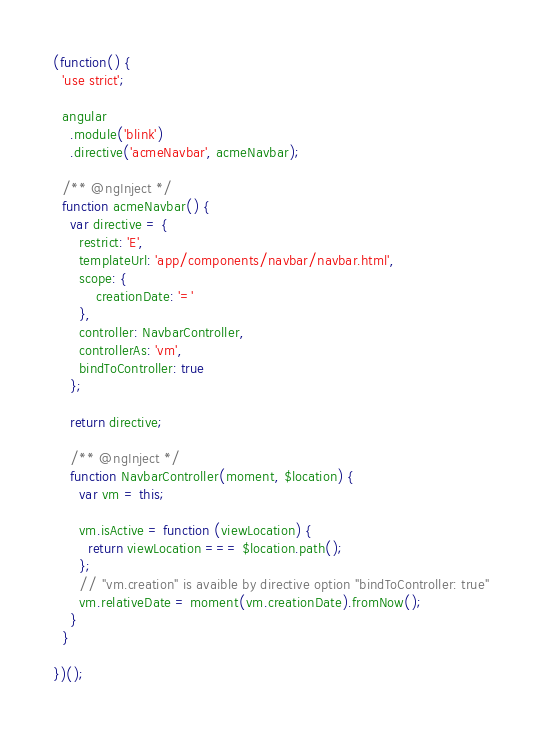Convert code to text. <code><loc_0><loc_0><loc_500><loc_500><_JavaScript_>(function() {
  'use strict';

  angular
    .module('blink')
    .directive('acmeNavbar', acmeNavbar);

  /** @ngInject */
  function acmeNavbar() {
    var directive = {
      restrict: 'E',
      templateUrl: 'app/components/navbar/navbar.html',
      scope: {
          creationDate: '='
      },
      controller: NavbarController,
      controllerAs: 'vm',
      bindToController: true
    };

    return directive;

    /** @ngInject */
    function NavbarController(moment, $location) {
      var vm = this;

      vm.isActive = function (viewLocation) {
        return viewLocation === $location.path();
      };
      // "vm.creation" is avaible by directive option "bindToController: true"
      vm.relativeDate = moment(vm.creationDate).fromNow();
    }
  }

})();
</code> 